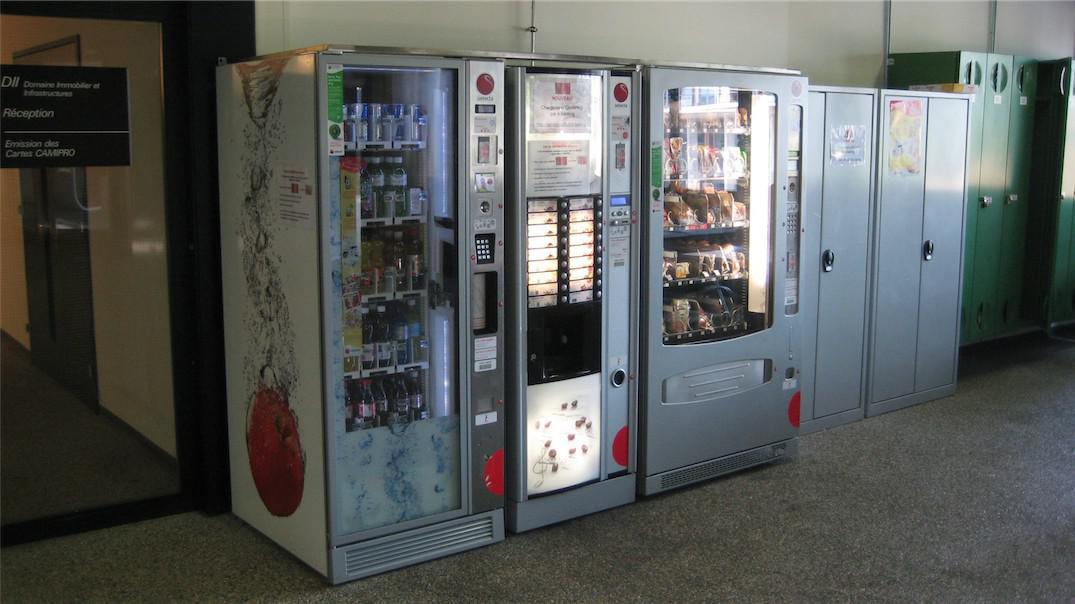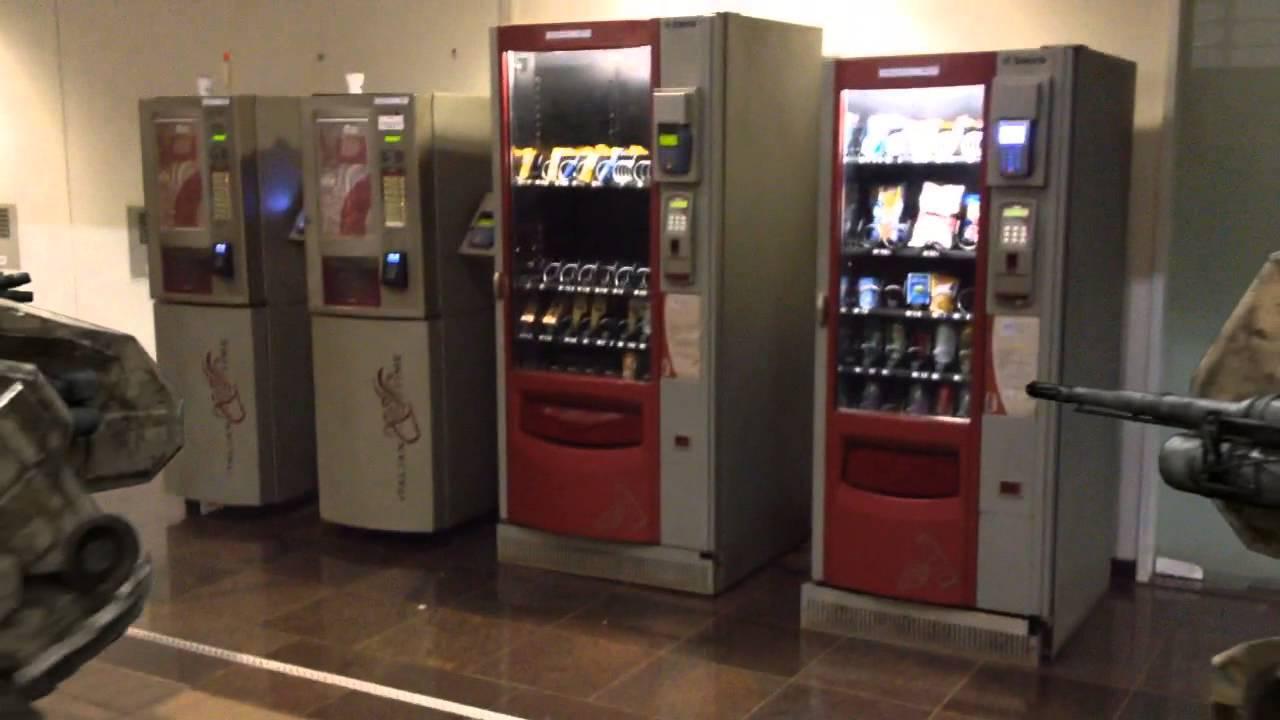The first image is the image on the left, the second image is the image on the right. Examine the images to the left and right. Is the description "In one image, a row of three vending machines are the same height." accurate? Answer yes or no. Yes. 